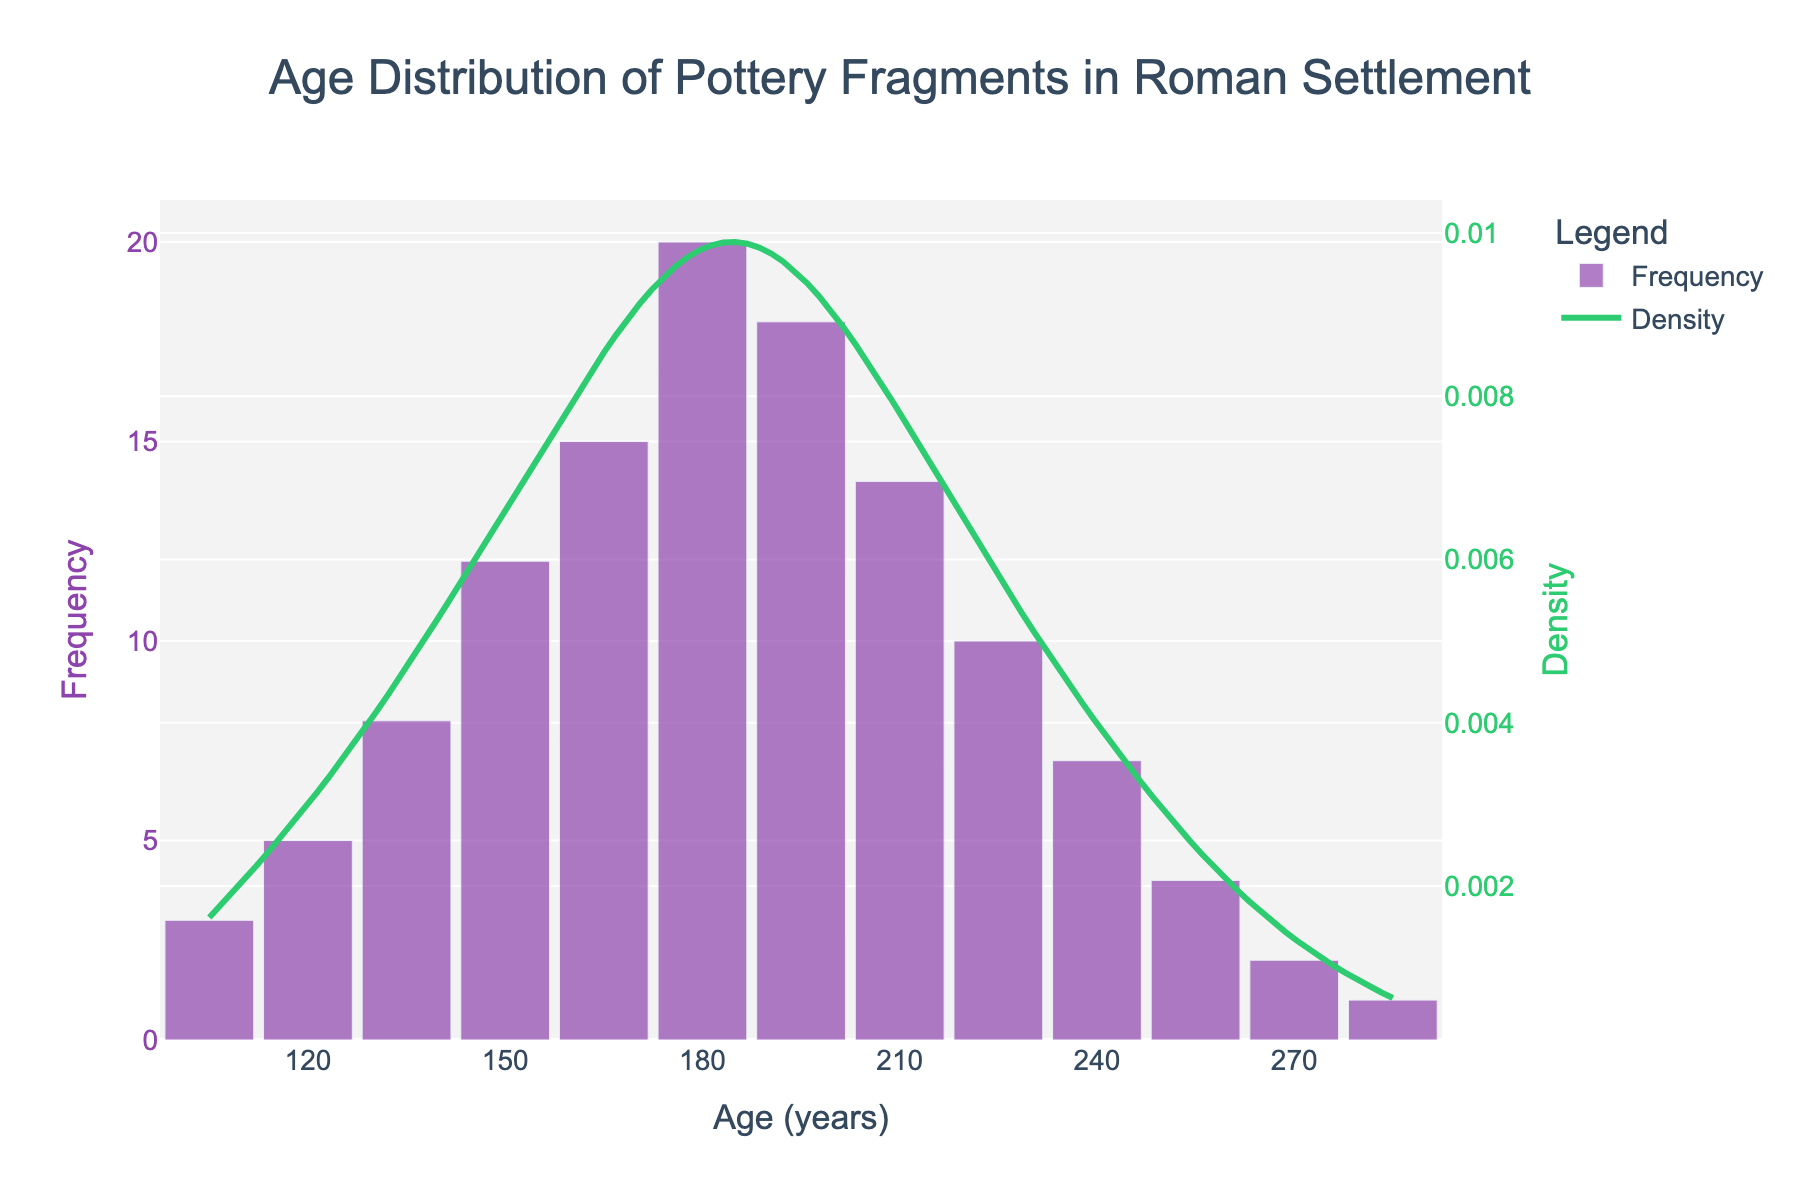How many distinct age categories of pottery fragments are displayed in the histogram? Count the number of distinct age categories on the x-axis of the histogram.
Answer: 13 What is the age with the highest frequency of pottery fragments? Look for the tallest bar in the histogram, which represents the highest frequency value.
Answer: 180 years How does the density curve change between the ages of 150 and 180 years? Observe the shape of the KDE curve between the x-values of 150 and 180 years to describe the trend.
Answer: It increases What is the combined frequency of pottery fragments for ages less than or equal to 135 years? Add up the frequencies for the age categories 105, 120, and 135 years (3 + 5 + 8).
Answer: 16 Which age category has a lower frequency: 210 years or 225 years? Compare the heights of the bars for the age categories 210 and 225 years.
Answer: 225 years In which year range does the histogram show the most significant drop in frequency? Identify the age range where the frequency changes most drastically by comparing the heights of adjacent bars.
Answer: 195 to 270 years Is the density highest at the same age as the highest frequency? Check the peak of the KDE curve and see if it aligns with the age where the tallest bar is located.
Answer: Yes What is the frequency difference between the youngest (105 years) and oldest (285 years) pottery fragments? Subtract the frequency of the oldest age (1) from the youngest age (3).
Answer: 2 How many age categories have a frequency greater than 10? Count the bars in the histogram that have heights greater than 10.
Answer: 4 What can be inferred about the central tendency of the age distribution from the histogram and KDE curve? Analyze the histogram and the peak(s) of the KDE curve to infer the central tendency. The peak of the KDE curve indicates the age range with the highest density of data points.
Answer: The central tendency is around 180 to 195 years 